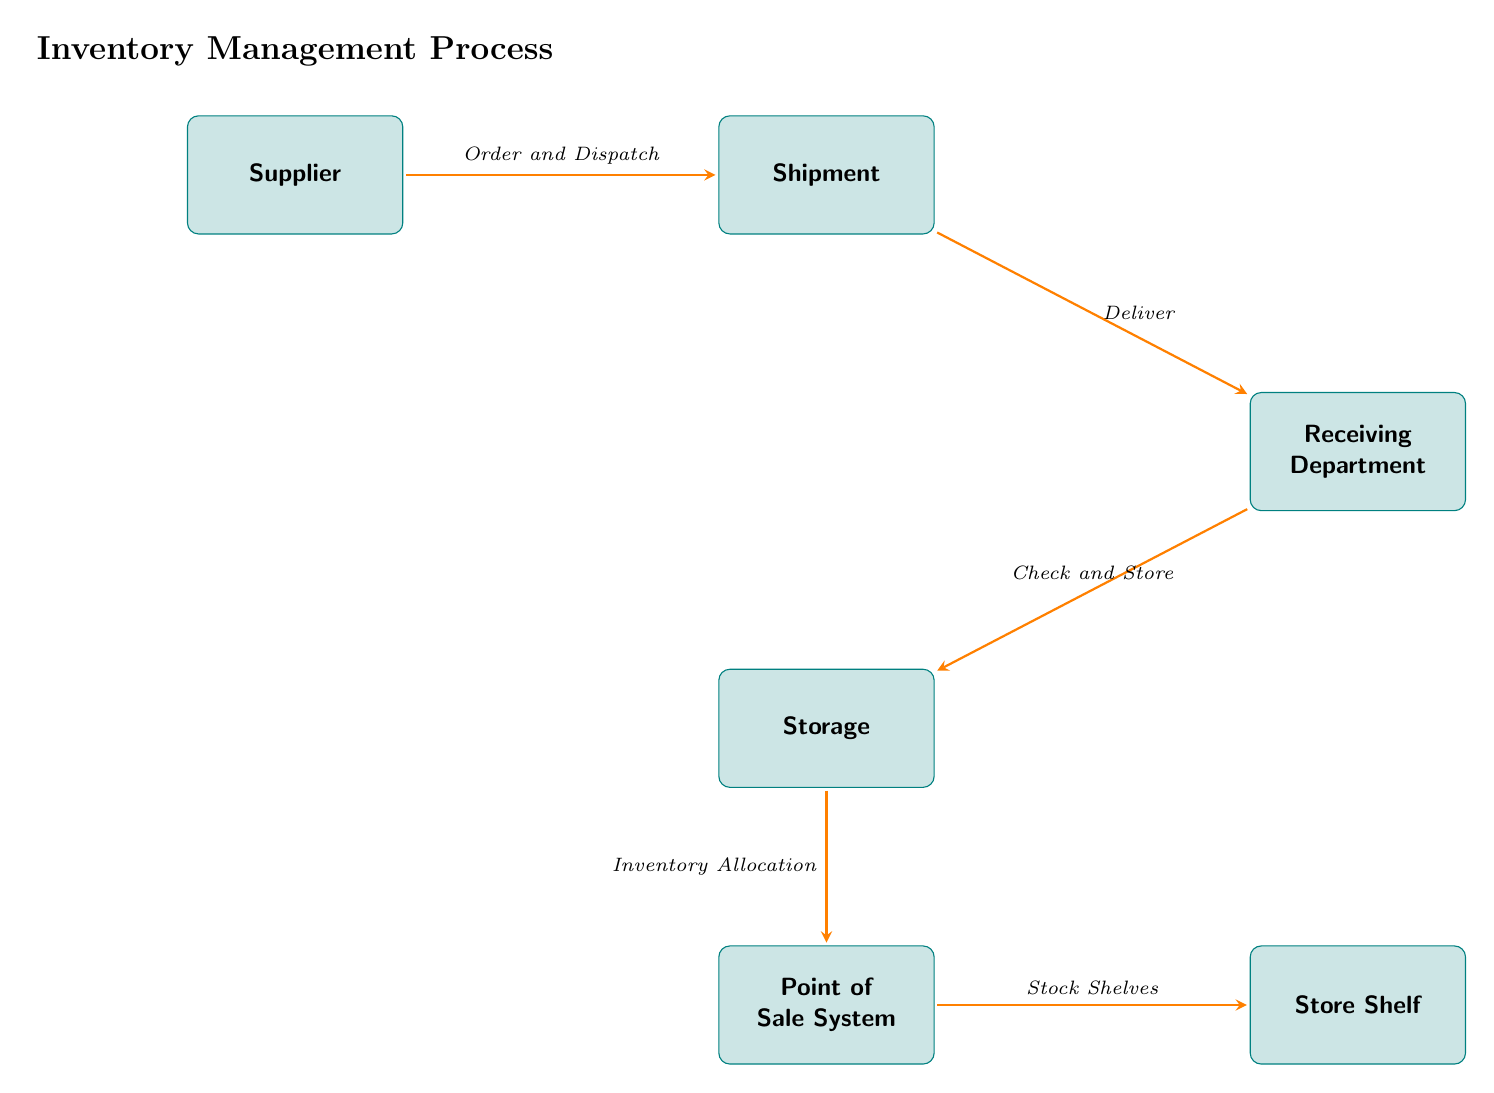What is the first node in the inventory management process? The first node in the process is "Supplier," as it is positioned at the start of the flow, indicating the origin of the inventory process.
Answer: Supplier How many nodes are present in the diagram? To find the number of nodes, we can count each distinct box in the diagram. The nodes are Supplier, Shipment, Receiving Department, Storage, Point of Sale System, and Store Shelf. This yields a total of six nodes.
Answer: 6 What is the last step before the products reach the store shelf? The last step before the products are placed on the store shelf is "Stock Shelves," as indicated by the flow of arrows leading to the final node.
Answer: Stock Shelves Which department checks and stores the inventory? The "Receiving Department" is responsible for checking and storing the inventory, as indicated by the labels and flow in the diagram.
Answer: Receiving Department What action follows after the delivery of the shipment? After the delivery of the shipment, the next action is "Check and Store," which involves receiving and processing the inventory for storage.
Answer: Check and Store How are the inventory items allocated? Inventory items are allocated through the "Inventory Allocation" process, which occurs after the items are stored and before they reach the Point of Sale System.
Answer: Inventory Allocation What is the relationship between "Storage" and "Point of Sale System"? The relationship between "Storage" and "Point of Sale System" is described as "Inventory Allocation," indicating that inventory in storage is assigned to the sales system.
Answer: Inventory Allocation What is the title of the diagram? The title of the diagram is "Inventory Management Process," which summarizes the focus of the visual representation.
Answer: Inventory Management Process 